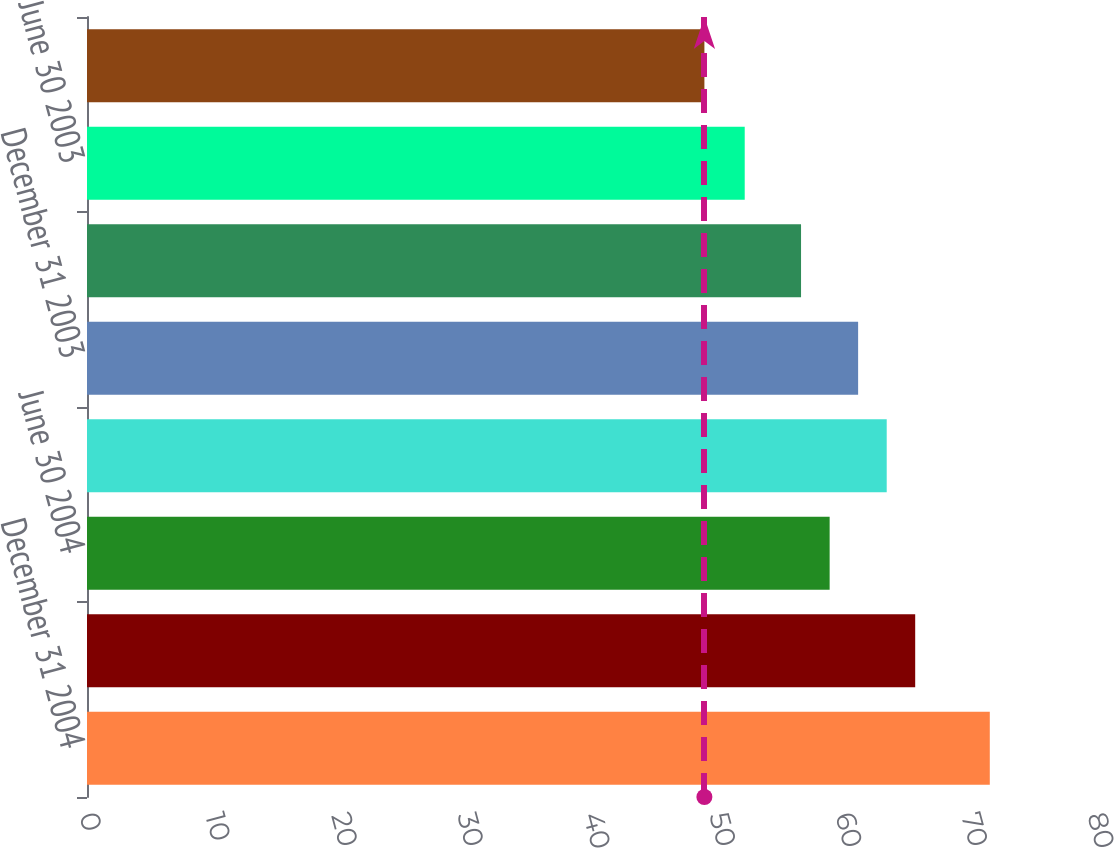<chart> <loc_0><loc_0><loc_500><loc_500><bar_chart><fcel>December 31 2004<fcel>September 30 2004<fcel>June 30 2004<fcel>March 31 2004<fcel>December 31 2003<fcel>September 30 2003<fcel>June 30 2003<fcel>March 31 2003<nl><fcel>71.65<fcel>65.73<fcel>58.94<fcel>63.47<fcel>61.2<fcel>56.67<fcel>52.2<fcel>49<nl></chart> 